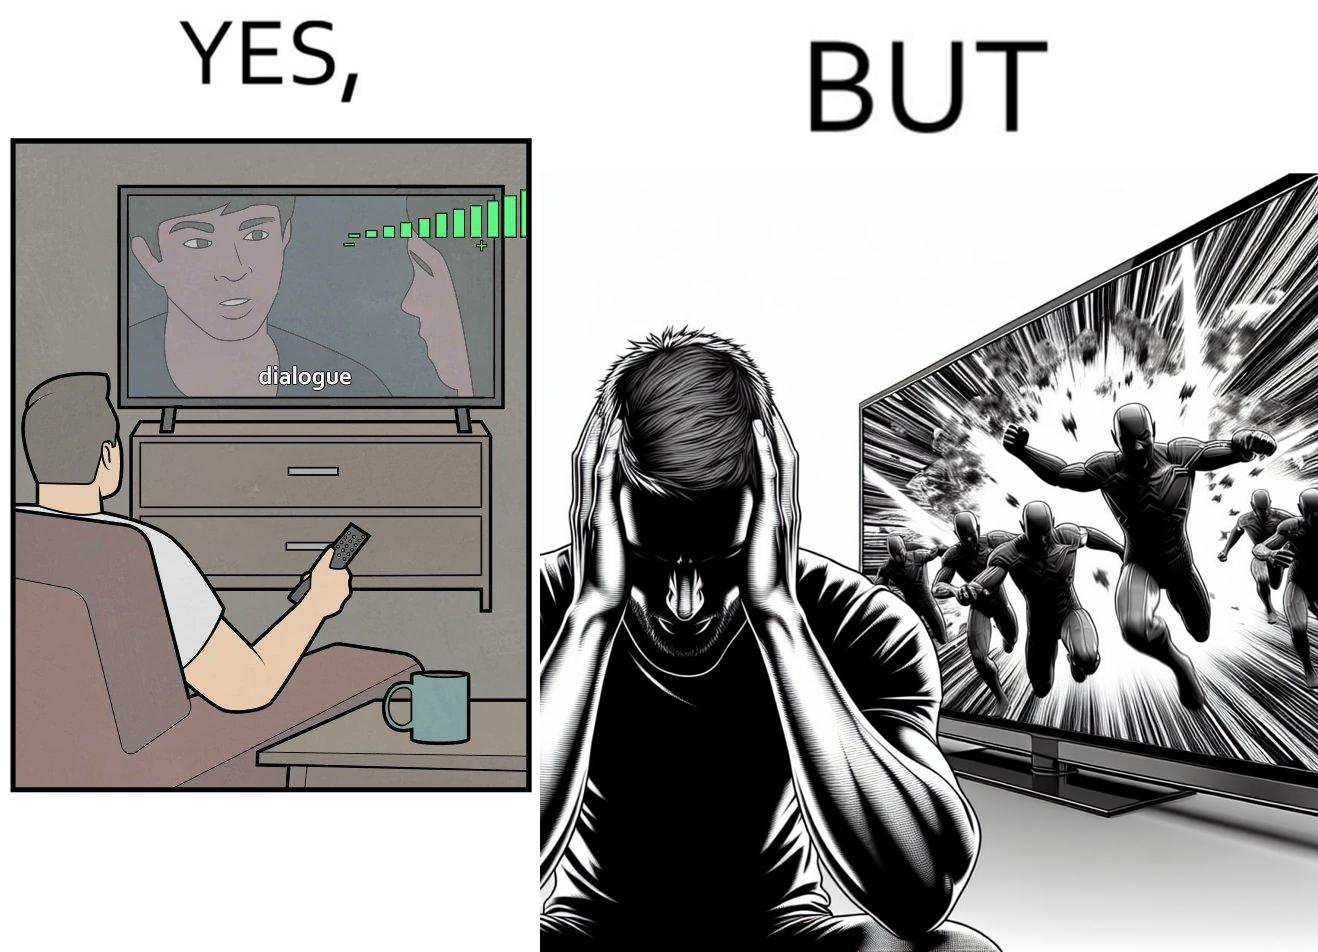Is there satirical content in this image? Yes, this image is satirical. 